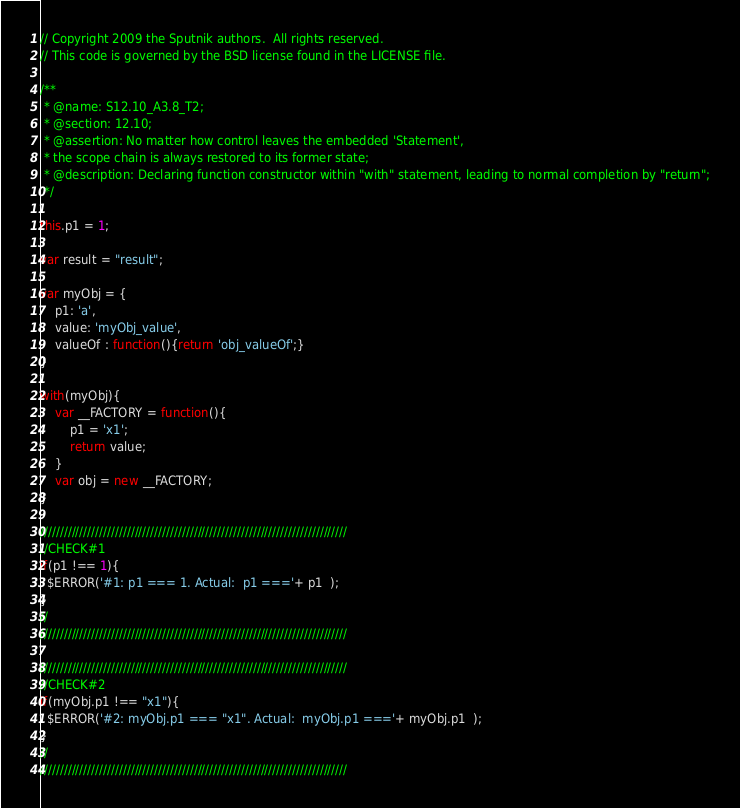Convert code to text. <code><loc_0><loc_0><loc_500><loc_500><_JavaScript_>// Copyright 2009 the Sputnik authors.  All rights reserved.
// This code is governed by the BSD license found in the LICENSE file.

/**
 * @name: S12.10_A3.8_T2;
 * @section: 12.10;
 * @assertion: No matter how control leaves the embedded 'Statement', 
 * the scope chain is always restored to its former state;
 * @description: Declaring function constructor within "with" statement, leading to normal completion by "return";
 */
 
this.p1 = 1;

var result = "result";

var myObj = {
    p1: 'a', 
    value: 'myObj_value',
    valueOf : function(){return 'obj_valueOf';}
}

with(myObj){
    var __FACTORY = function(){
        p1 = 'x1';
        return value;
    }
    var obj = new __FACTORY;
}

//////////////////////////////////////////////////////////////////////////////
//CHECK#1
if(p1 !== 1){
  $ERROR('#1: p1 === 1. Actual:  p1 ==='+ p1  );
}
//
//////////////////////////////////////////////////////////////////////////////

//////////////////////////////////////////////////////////////////////////////
//CHECK#2
if(myObj.p1 !== "x1"){
  $ERROR('#2: myObj.p1 === "x1". Actual:  myObj.p1 ==='+ myObj.p1  );
}
//
//////////////////////////////////////////////////////////////////////////////
</code> 